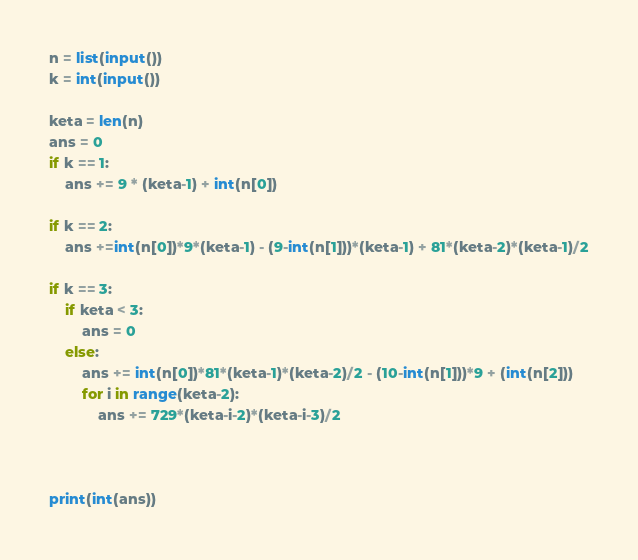<code> <loc_0><loc_0><loc_500><loc_500><_Python_>n = list(input())
k = int(input())

keta = len(n)
ans = 0
if k == 1:
    ans += 9 * (keta-1) + int(n[0])
    
if k == 2:
    ans +=int(n[0])*9*(keta-1) - (9-int(n[1]))*(keta-1) + 81*(keta-2)*(keta-1)/2

if k == 3:
    if keta < 3:
        ans = 0
    else:
        ans += int(n[0])*81*(keta-1)*(keta-2)/2 - (10-int(n[1]))*9 + (int(n[2]))
        for i in range(keta-2):
            ans += 729*(keta-i-2)*(keta-i-3)/2



print(int(ans))</code> 